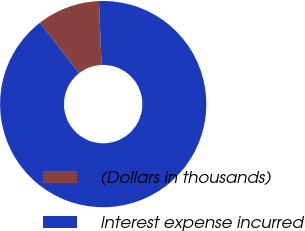<chart> <loc_0><loc_0><loc_500><loc_500><pie_chart><fcel>(Dollars in thousands)<fcel>Interest expense incurred<nl><fcel>9.88%<fcel>90.12%<nl></chart> 